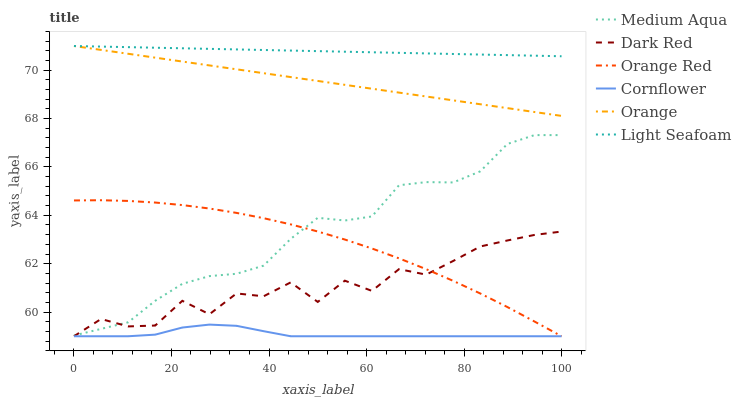Does Cornflower have the minimum area under the curve?
Answer yes or no. Yes. Does Light Seafoam have the maximum area under the curve?
Answer yes or no. Yes. Does Dark Red have the minimum area under the curve?
Answer yes or no. No. Does Dark Red have the maximum area under the curve?
Answer yes or no. No. Is Orange the smoothest?
Answer yes or no. Yes. Is Dark Red the roughest?
Answer yes or no. Yes. Is Medium Aqua the smoothest?
Answer yes or no. No. Is Medium Aqua the roughest?
Answer yes or no. No. Does Medium Aqua have the lowest value?
Answer yes or no. No. Does Light Seafoam have the highest value?
Answer yes or no. Yes. Does Dark Red have the highest value?
Answer yes or no. No. Is Cornflower less than Light Seafoam?
Answer yes or no. Yes. Is Light Seafoam greater than Cornflower?
Answer yes or no. Yes. Does Cornflower intersect Light Seafoam?
Answer yes or no. No. 